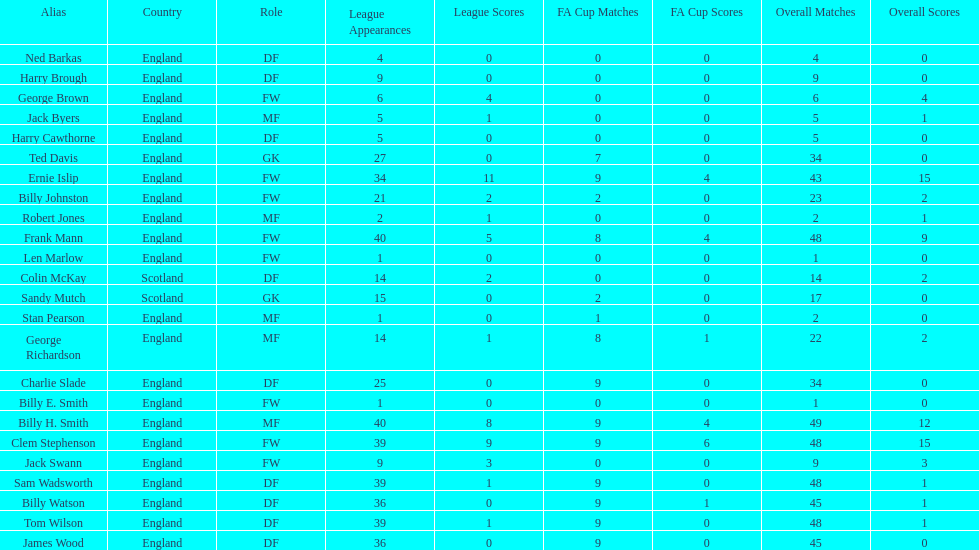Give me the full table as a dictionary. {'header': ['Alias', 'Country', 'Role', 'League Appearances', 'League Scores', 'FA Cup Matches', 'FA Cup Scores', 'Overall Matches', 'Overall Scores'], 'rows': [['Ned Barkas', 'England', 'DF', '4', '0', '0', '0', '4', '0'], ['Harry Brough', 'England', 'DF', '9', '0', '0', '0', '9', '0'], ['George Brown', 'England', 'FW', '6', '4', '0', '0', '6', '4'], ['Jack Byers', 'England', 'MF', '5', '1', '0', '0', '5', '1'], ['Harry Cawthorne', 'England', 'DF', '5', '0', '0', '0', '5', '0'], ['Ted Davis', 'England', 'GK', '27', '0', '7', '0', '34', '0'], ['Ernie Islip', 'England', 'FW', '34', '11', '9', '4', '43', '15'], ['Billy Johnston', 'England', 'FW', '21', '2', '2', '0', '23', '2'], ['Robert Jones', 'England', 'MF', '2', '1', '0', '0', '2', '1'], ['Frank Mann', 'England', 'FW', '40', '5', '8', '4', '48', '9'], ['Len Marlow', 'England', 'FW', '1', '0', '0', '0', '1', '0'], ['Colin McKay', 'Scotland', 'DF', '14', '2', '0', '0', '14', '2'], ['Sandy Mutch', 'Scotland', 'GK', '15', '0', '2', '0', '17', '0'], ['Stan Pearson', 'England', 'MF', '1', '0', '1', '0', '2', '0'], ['George Richardson', 'England', 'MF', '14', '1', '8', '1', '22', '2'], ['Charlie Slade', 'England', 'DF', '25', '0', '9', '0', '34', '0'], ['Billy E. Smith', 'England', 'FW', '1', '0', '0', '0', '1', '0'], ['Billy H. Smith', 'England', 'MF', '40', '8', '9', '4', '49', '12'], ['Clem Stephenson', 'England', 'FW', '39', '9', '9', '6', '48', '15'], ['Jack Swann', 'England', 'FW', '9', '3', '0', '0', '9', '3'], ['Sam Wadsworth', 'England', 'DF', '39', '1', '9', '0', '48', '1'], ['Billy Watson', 'England', 'DF', '36', '0', '9', '1', '45', '1'], ['Tom Wilson', 'England', 'DF', '39', '1', '9', '0', '48', '1'], ['James Wood', 'England', 'DF', '36', '0', '9', '0', '45', '0']]} The least number of total appearances 1. 